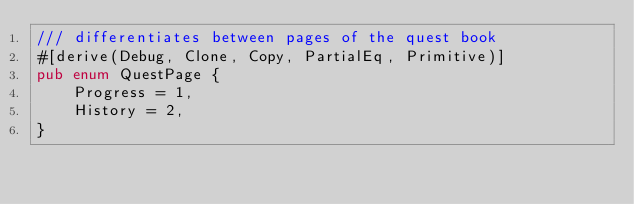<code> <loc_0><loc_0><loc_500><loc_500><_Rust_>/// differentiates between pages of the quest book
#[derive(Debug, Clone, Copy, PartialEq, Primitive)]
pub enum QuestPage {
    Progress = 1,
    History = 2,
}
</code> 